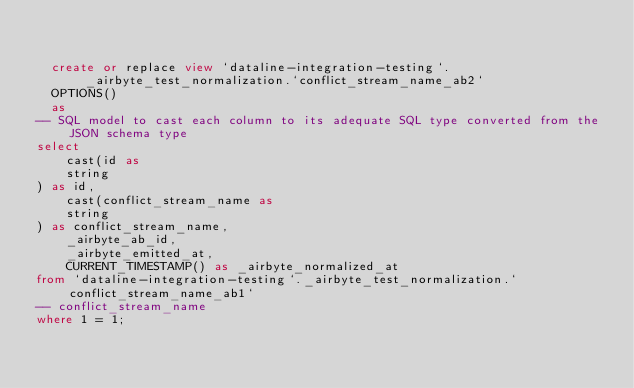<code> <loc_0><loc_0><loc_500><loc_500><_SQL_>

  create or replace view `dataline-integration-testing`._airbyte_test_normalization.`conflict_stream_name_ab2`
  OPTIONS()
  as 
-- SQL model to cast each column to its adequate SQL type converted from the JSON schema type
select
    cast(id as 
    string
) as id,
    cast(conflict_stream_name as 
    string
) as conflict_stream_name,
    _airbyte_ab_id,
    _airbyte_emitted_at,
    CURRENT_TIMESTAMP() as _airbyte_normalized_at
from `dataline-integration-testing`._airbyte_test_normalization.`conflict_stream_name_ab1`
-- conflict_stream_name
where 1 = 1;

</code> 